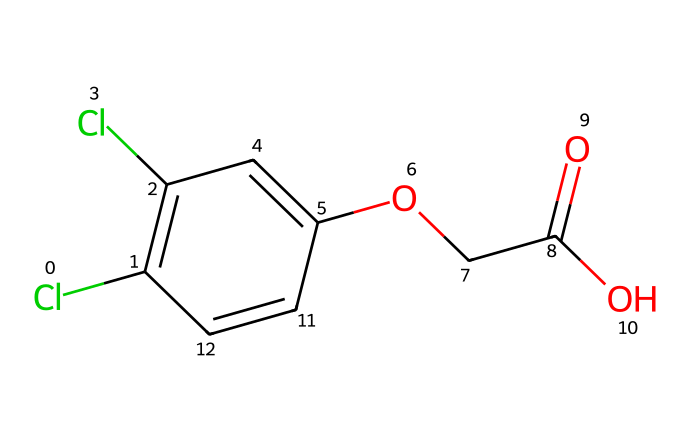What is the molecular formula of 2,4-Dichlorophenoxyacetic acid? To determine the molecular formula, we analyze the chemical structure represented by the SMILES. Counting the carbon (C), hydrogen (H), chlorine (Cl), and oxygen (O) atoms gives us: 10 carbons, 9 hydrogens, 2 chlorines, and 4 oxygens. So, the molecular formula is C10H9Cl2O4.
Answer: C10H9Cl2O4 How many chlorine atoms are present in 2,4-D? By examining the SMILES structure, we see two 'Cl' notations, indicating two chlorine atoms. Therefore, the count is straightforward.
Answer: 2 What functional groups are present in this herbicide? A closer look at the structure reveals a carboxylic acid group (-COOH), an ether group (-O-), and aryl rings (the phenoxy group). Identifying these functional groups leads us to conclude this specific combination is characteristic of herbicides like 2,4-D.
Answer: carboxylic acid, ether, aryl rings Why is the presence of chlorine atoms significant in this herbicide? Chlorine atoms in 2,4-D contribute to its herbicidal activity and persistence in the environment. The electronegative chlorine atoms enhance the compound's ability to disrupt plant growth hormones, which is a critical mechanism of action for herbicides.
Answer: disrupts plant hormones What is the primary mode of action of 2,4-D? The primary mechanism of action for 2,4-D is known to mimic natural plant hormones (auxins), leading to uncontrolled growth and ultimately plant death. This action is facilitated by its chemical structure, particularly the carboxylic acid portion and the phenoxy group.
Answer: mimics plant hormones How many rings are there in the structure of 2,4-D? Analyzing the SMILES, we find one aromatic ring indicated by the notation of 'C' and '=' within C1= and C1 in the structure. Therefore, there is one central ring present in C10H9Cl2O4.
Answer: 1 